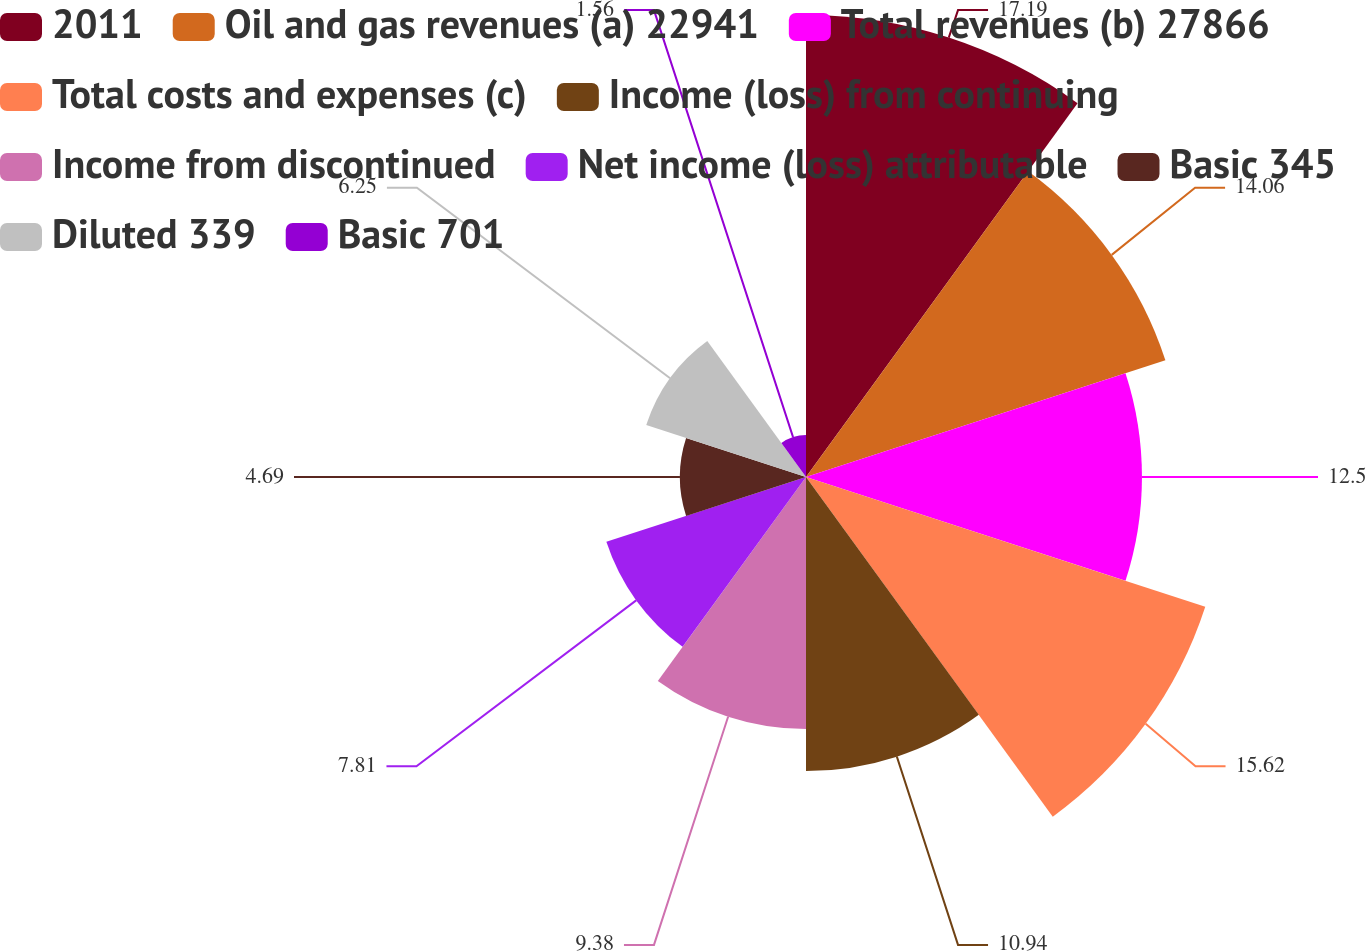<chart> <loc_0><loc_0><loc_500><loc_500><pie_chart><fcel>2011<fcel>Oil and gas revenues (a) 22941<fcel>Total revenues (b) 27866<fcel>Total costs and expenses (c)<fcel>Income (loss) from continuing<fcel>Income from discontinued<fcel>Net income (loss) attributable<fcel>Basic 345<fcel>Diluted 339<fcel>Basic 701<nl><fcel>17.19%<fcel>14.06%<fcel>12.5%<fcel>15.62%<fcel>10.94%<fcel>9.38%<fcel>7.81%<fcel>4.69%<fcel>6.25%<fcel>1.56%<nl></chart> 